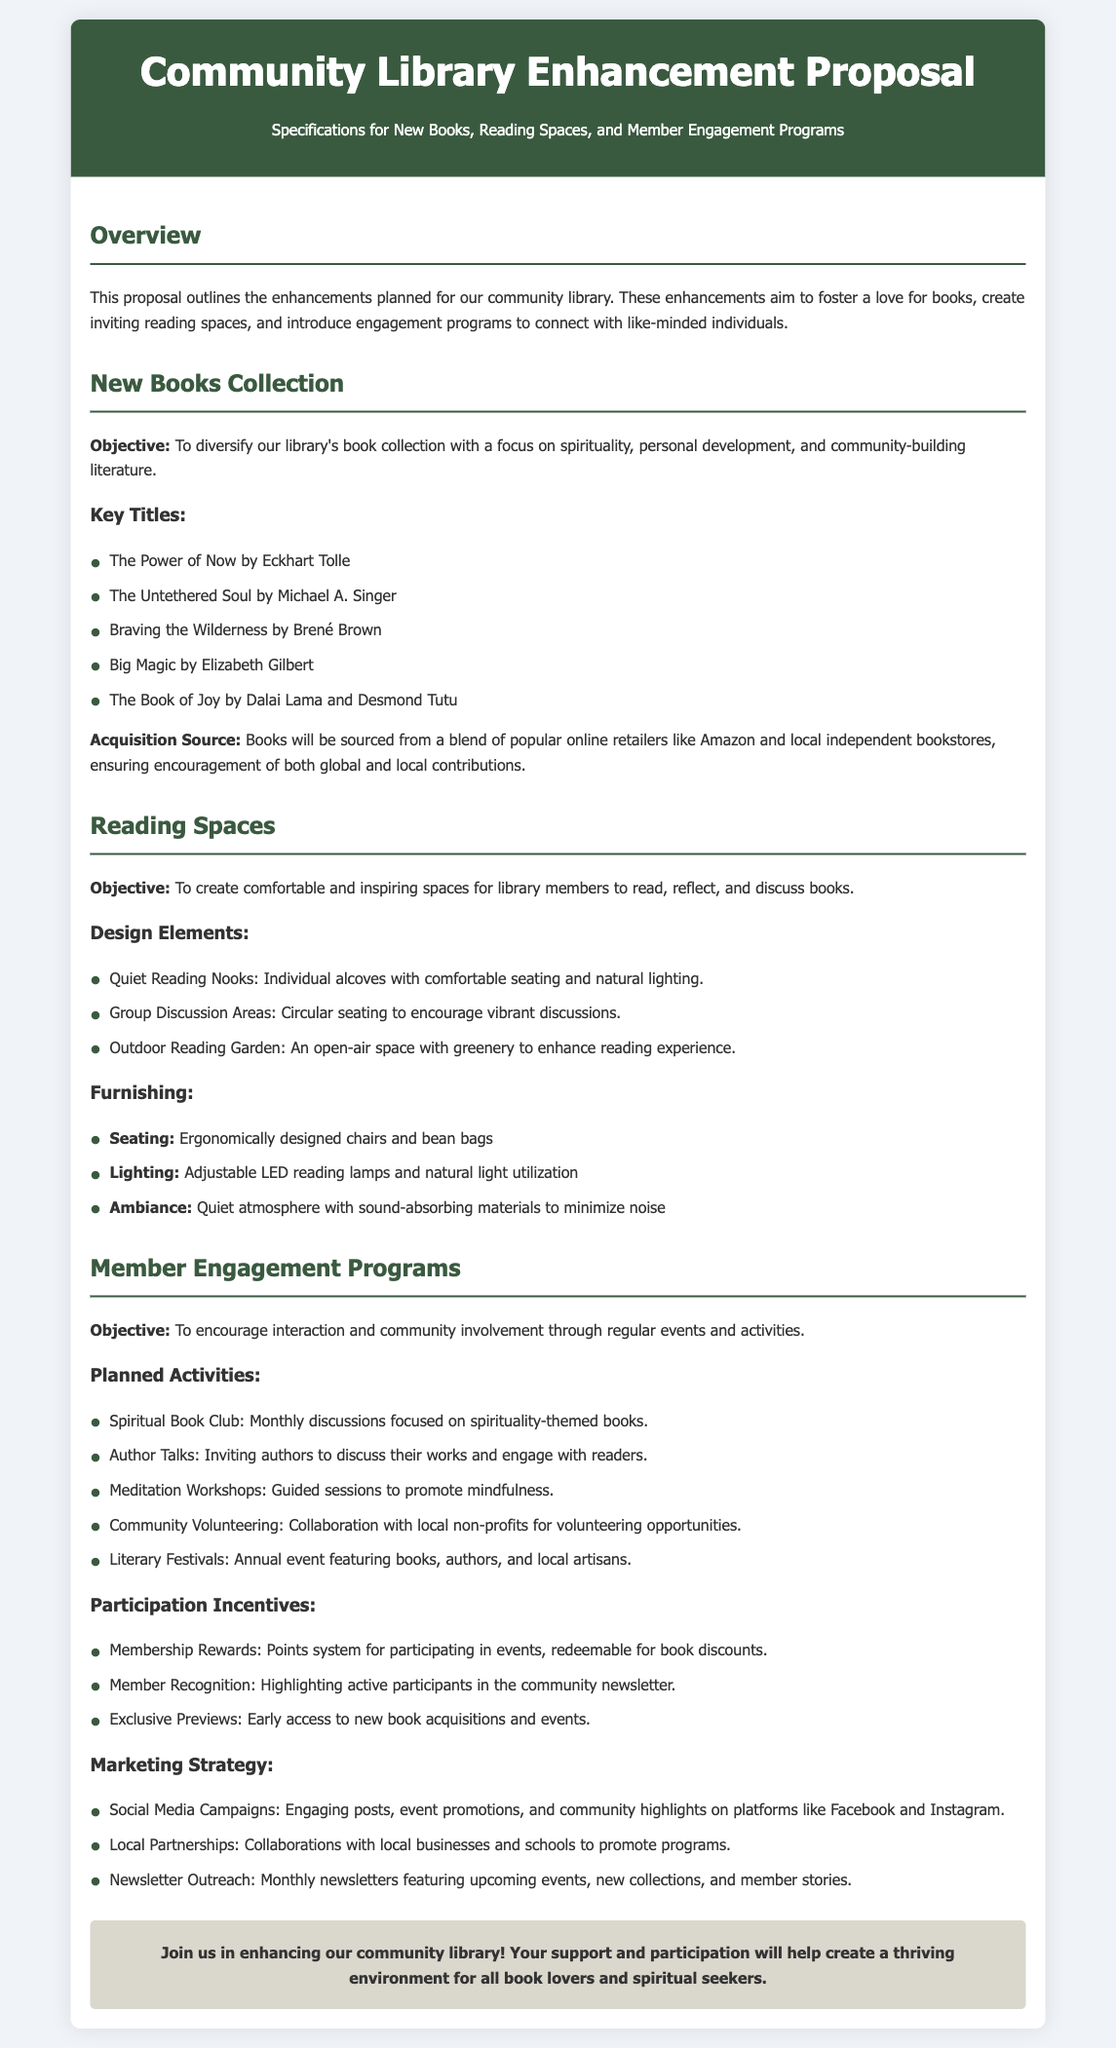What are the key titles in the new books collection? The key titles in the new books collection are listed in the section "New Books Collection" under "Key Titles," including specific books geared towards spirituality and personal development.
Answer: The Power of Now, The Untethered Soul, Braving the Wilderness, Big Magic, The Book of Joy What is the objective of the member engagement programs? The objective of the member engagement programs is stated in the section "Member Engagement Programs." It outlines the focus on encouraging interaction and community involvement.
Answer: To encourage interaction and community involvement What type of seating will be provided in the reading spaces? The type of seating is detailed in the "Furnishing" section under "Reading Spaces," highlighting different seating options.
Answer: Ergonomically designed chairs and bean bags How many planned activities are mentioned in the member engagement programs? The number of planned activities can be counted in the "Planned Activities" subsection, giving an overview of the types of programs.
Answer: Five What are the participation incentives for members? The participation incentives are outlined in the section "Participation Incentives" in the "Member Engagement Programs." This section details various rewards for active participation.
Answer: Membership Rewards, Member Recognition, Exclusive Previews What is one of the design elements included in the reading spaces? A specific design element can be found under "Design Elements" in the "Reading Spaces" section, indicating different features of the reading environment.
Answer: Quiet Reading Nooks What sources are used to acquire new books? The sourcing of new books is mentioned specifically in the "Acquisition Source" subsection within "New Books Collection," indicating where the books will come from.
Answer: Popular online retailers and local independent bookstores What is the background color of the header in the document? The background color detail is typically part of the styling defined at the beginning of the document, lending to the overall aesthetic appearance.
Answer: Dark green 